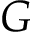Convert formula to latex. <formula><loc_0><loc_0><loc_500><loc_500>G</formula> 